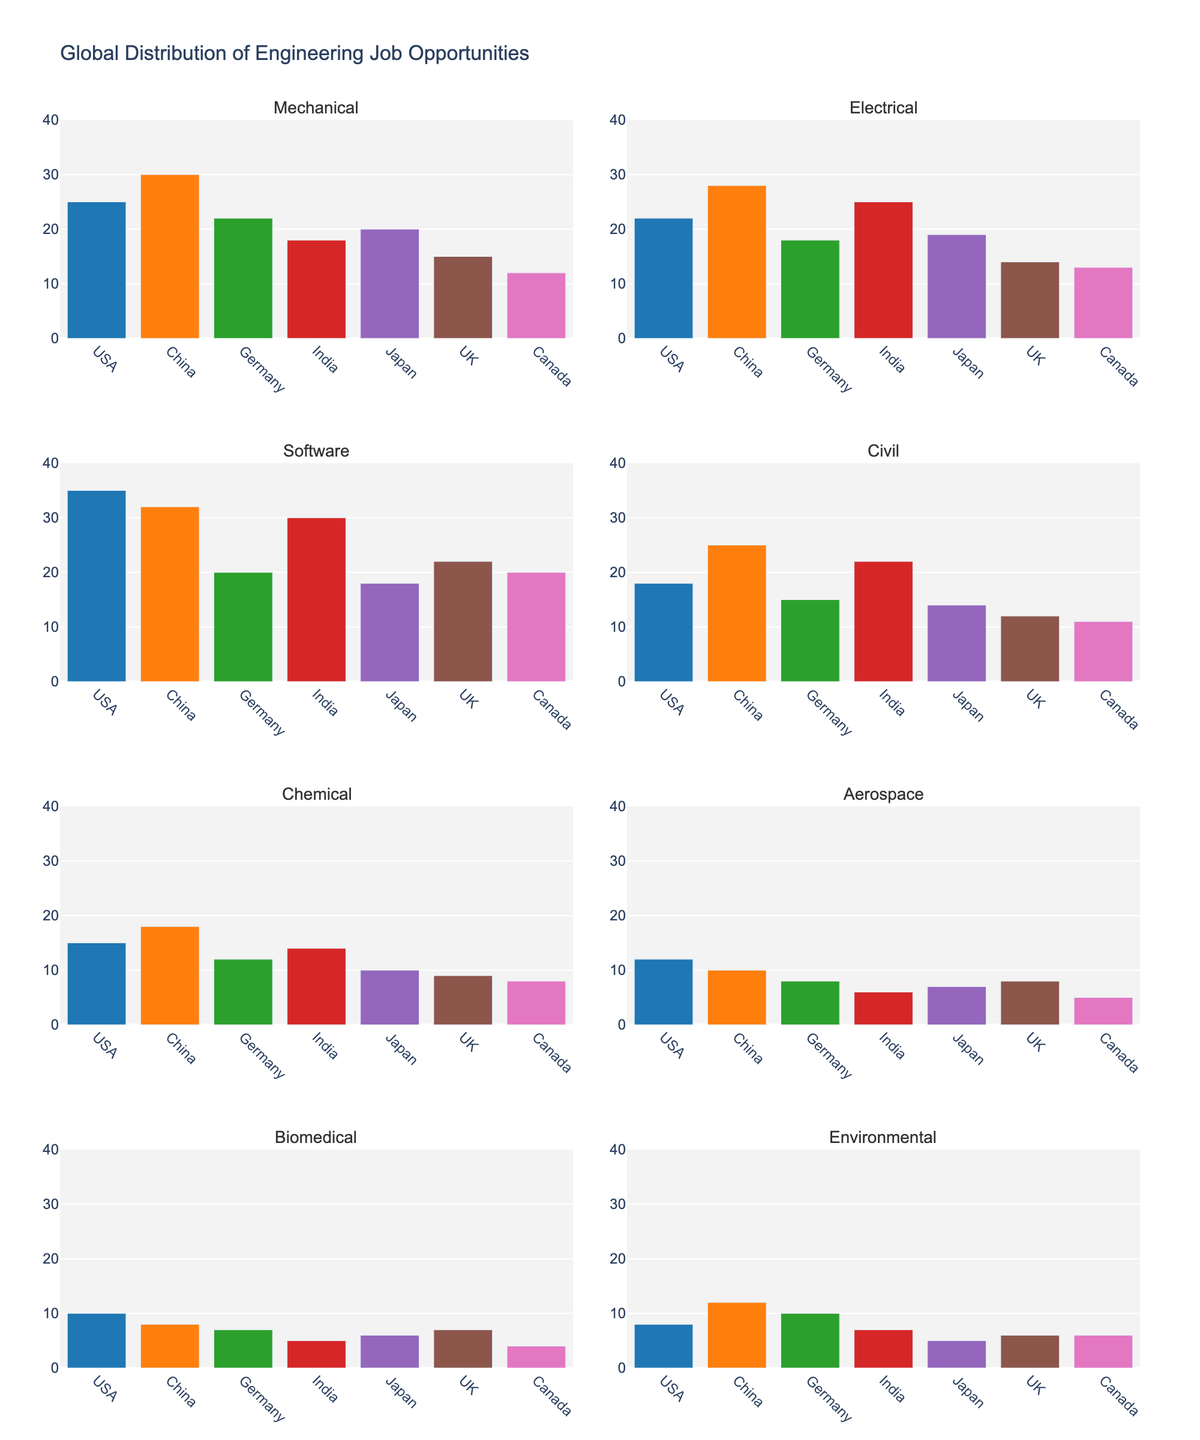What year had the highest number of monuments inaugurated? The year with the highest number of monuments inaugurated can be found by looking at the bar with the greatest height in the top subplot. It is 2017 with 8 monuments inaugurated.
Answer: 2017 How many years are displayed in the figure? Each tick on the x-axis of the bar chart represents a year. By counting these ticks, we see there are 10 years displayed in the figure.
Answer: 10 What is the political significance rating for the year Finland joined the UN? To find the political significance for 1955, locate the corresponding point in the lower subplot under "Political Significance." It shows a rating of 8.
Answer: 8 Which event is associated with the lowest number of monuments inaugurated? The lowest bar in the "Monuments Inaugurated" subplot represents the event with the fewest monuments. The bar for 1939 shows only 1 monument inaugurated, corresponding to the "Winter War Begins" event.
Answer: Winter War Begins (1939) What is the correlation between the number of monuments inaugurated and political significance? By comparing the two subplots, a pattern emerges where events with higher political significance tend to coincide with more monuments inaugurated, suggesting a positive correlation.
Answer: Positive correlation Compare the trends in monument inaugurations and political significance from 1917 to 2017. Over the years, both the number of monuments inaugurated and political significance ratings show an upward trend, with peaks in significant jubilee years and key historical milestones such as the Centenary of Independence in 2017.
Answer: Upward trend How many total monuments were inaugurated between 1917 and 2017? To find the total, sum the values from all bars in the top subplot. The values are 2, 5, 1, 3, 6, 4, 3, 5, 4, and 8. The total is 41.
Answer: 41 Between which two consecutive events was there the largest increase in the number of monuments inaugurated? By comparing consecutive bars, the largest increase is from 1944 (Continuation War Ends, 3) to 1952 (Helsinki Olympics, 6), resulting in an increase of 3.
Answer: 1944 to 1952 Which event corresponds to the highest political significance rating? The highest point in the "Political Significance" subplot is at a rating of 10. This corresponds to both "Finnish Independence" in 1917 and "Finland Joins EU" in 1995 and "Centenary of Independence" in 2017.
Answer: Finnish Independence, Finland Joins EU, Centenary of Independence What year shows a decrease in the number of monuments after showing an increase? Comparing the bars, the year 1955 (Finland Joins UN, 4) follows an increase (1952) and then shows a decrease in monuments inaugurated from 6 to 4.
Answer: 1955 